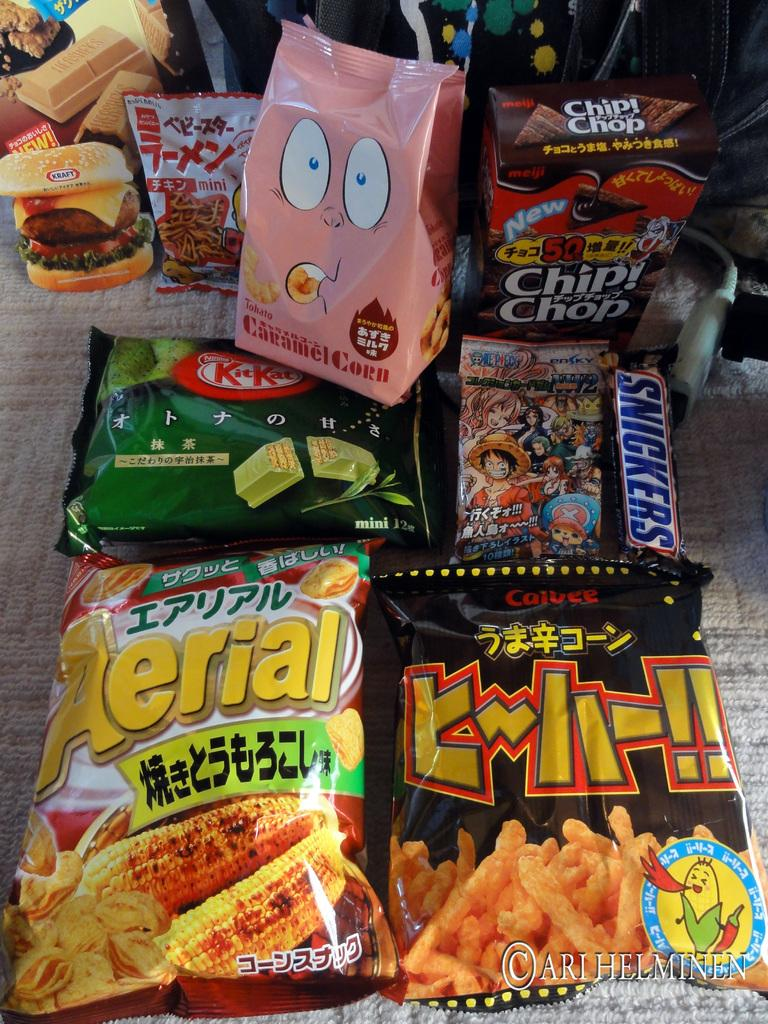What type of items are visible in the image? There are packaged food items in the image. What can be seen on the packaged food items? The packaged food items have text on them. Where are the packaged food items placed? The packaged food items are placed on a mat. What type of behavior can be observed in the packaged food items in the image? Packaged food items do not exhibit behavior, as they are inanimate objects. 